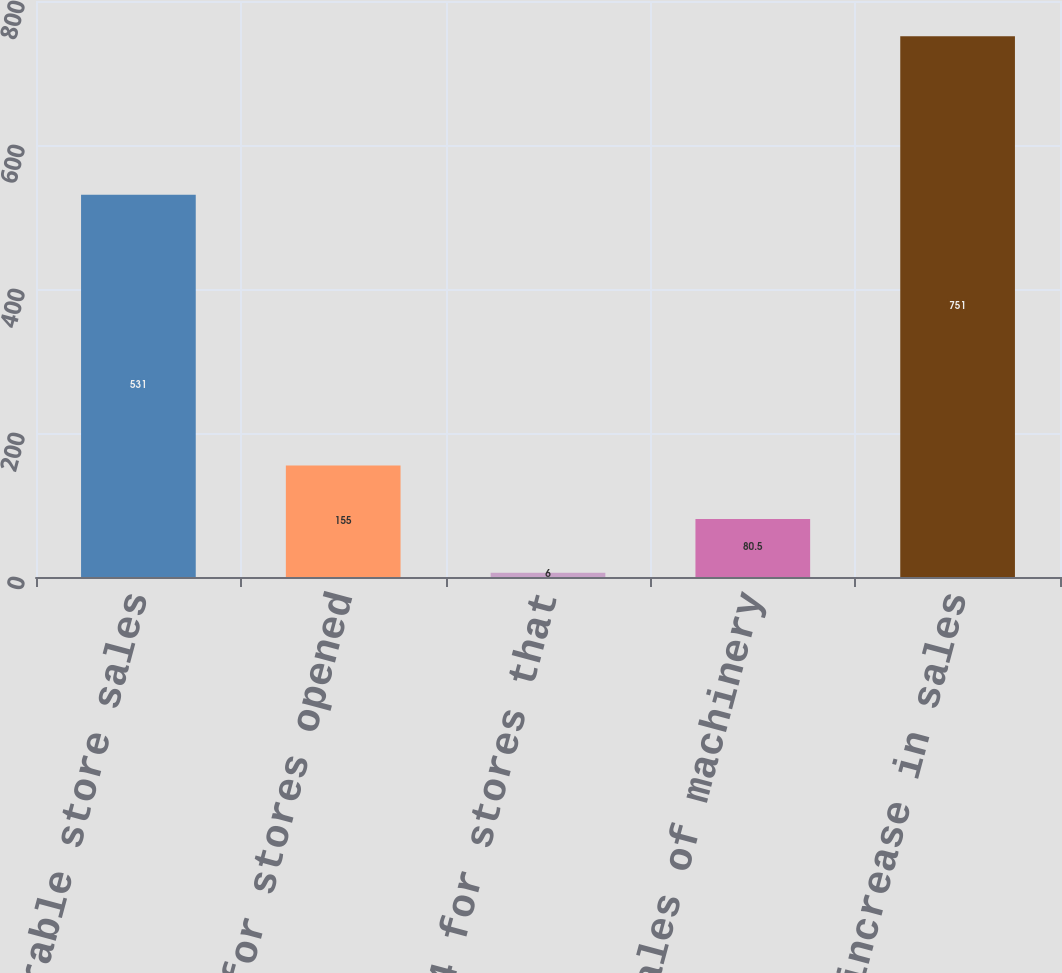Convert chart. <chart><loc_0><loc_0><loc_500><loc_500><bar_chart><fcel>Comparable store sales<fcel>Sales for stores opened<fcel>Sales in 2014 for stores that<fcel>Includes sales of machinery<fcel>Total increase in sales<nl><fcel>531<fcel>155<fcel>6<fcel>80.5<fcel>751<nl></chart> 